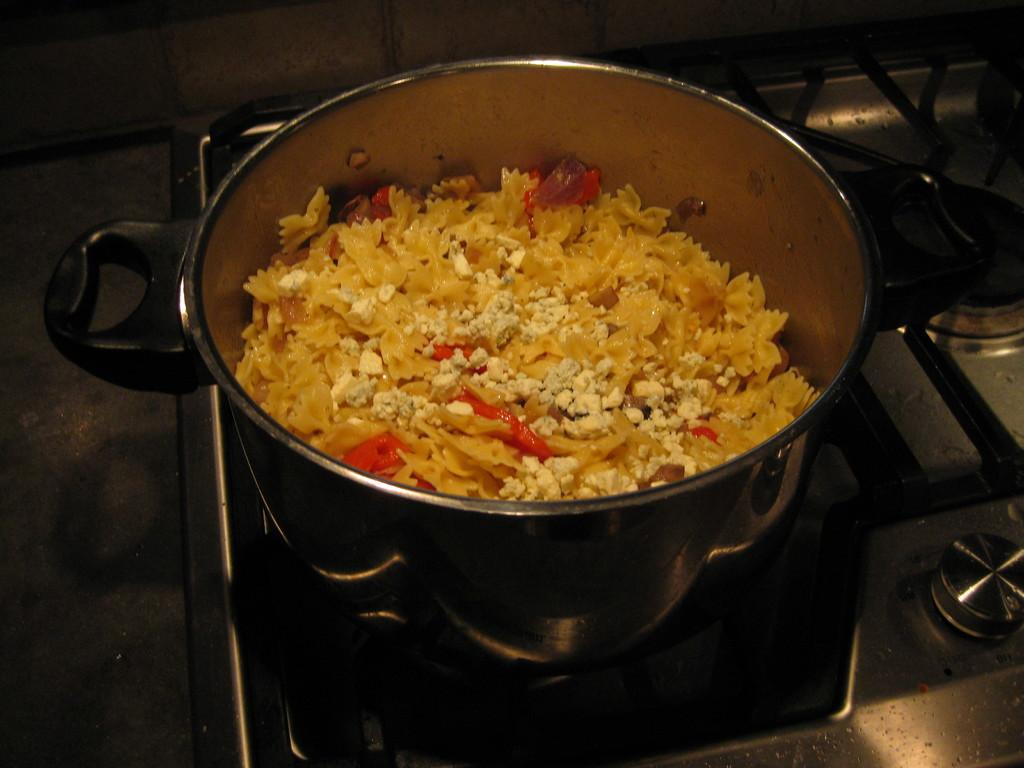What is inside the cooker that is visible in the image? There is a food item in the cooker in the image. What type of stove is the cooker placed on? The cooker is on a gas stove. What type of pig is visible in the image? There is no pig present in the image. What material is the cooker made of in the image? The provided facts do not mention the material of the cooker. 